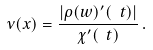<formula> <loc_0><loc_0><loc_500><loc_500>\nu ( x ) = \frac { | \rho ( w ) ^ { \prime } ( \ t ) | } { \chi ^ { \prime } ( \ t ) } \, .</formula> 